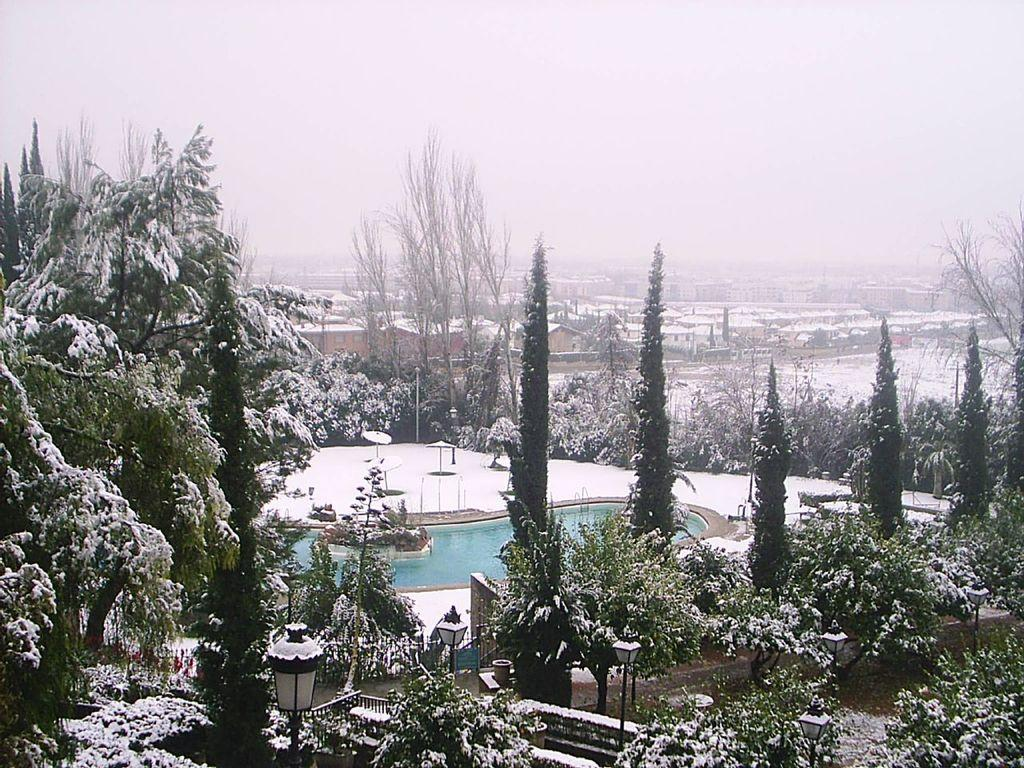What type of vegetation can be seen in the image? There are trees and plants in the image. What type of lighting is present in the image? There are street lamps in the image. What natural element is visible in the image? There is water visible in the image. What is the weather like in the image? There is snow in the image, indicating a cold or wintery environment. What type of structures are present in the image? There are houses in the image. What is visible at the top of the image? The sky is visible at the top of the image. Who is the writer in the image? There is no writer present in the image. Can you tell me how many drains are visible in the image? There are no drains visible in the image; the image features trees, street lamps, plants, water, snow, houses, and the sky. 